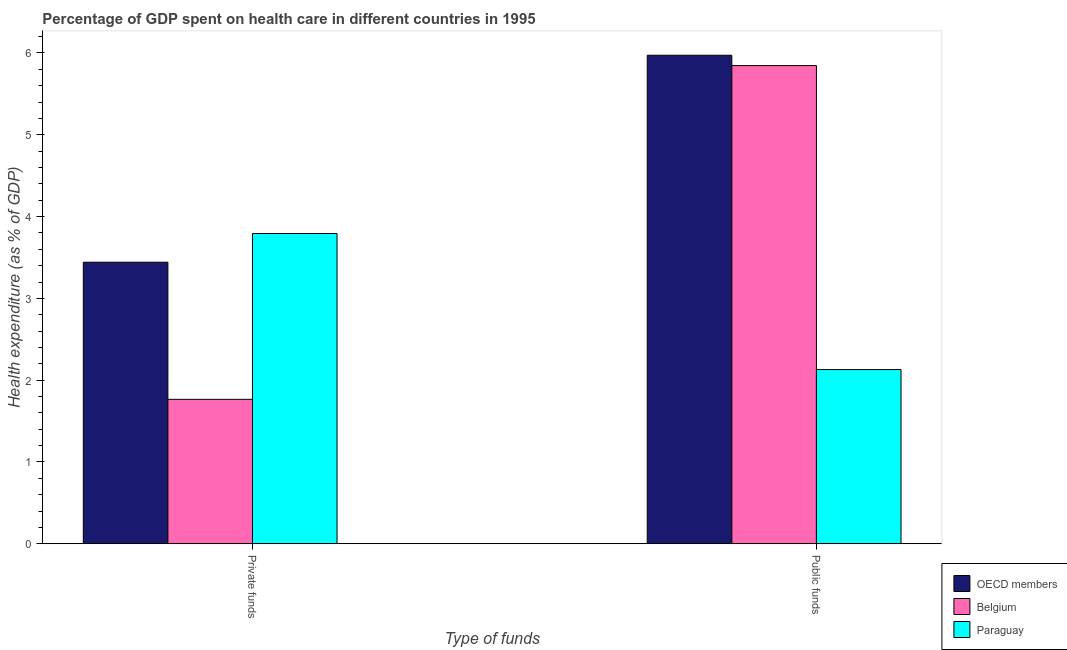How many different coloured bars are there?
Give a very brief answer. 3. Are the number of bars per tick equal to the number of legend labels?
Your answer should be very brief. Yes. How many bars are there on the 2nd tick from the left?
Make the answer very short. 3. What is the label of the 2nd group of bars from the left?
Provide a succinct answer. Public funds. What is the amount of public funds spent in healthcare in Belgium?
Keep it short and to the point. 5.85. Across all countries, what is the maximum amount of private funds spent in healthcare?
Offer a very short reply. 3.79. Across all countries, what is the minimum amount of private funds spent in healthcare?
Make the answer very short. 1.77. In which country was the amount of public funds spent in healthcare maximum?
Give a very brief answer. OECD members. In which country was the amount of private funds spent in healthcare minimum?
Your answer should be very brief. Belgium. What is the total amount of private funds spent in healthcare in the graph?
Make the answer very short. 9. What is the difference between the amount of public funds spent in healthcare in Paraguay and that in OECD members?
Offer a terse response. -3.84. What is the difference between the amount of public funds spent in healthcare in Paraguay and the amount of private funds spent in healthcare in Belgium?
Your answer should be compact. 0.36. What is the average amount of public funds spent in healthcare per country?
Your answer should be very brief. 4.65. What is the difference between the amount of private funds spent in healthcare and amount of public funds spent in healthcare in OECD members?
Offer a terse response. -2.53. What is the ratio of the amount of private funds spent in healthcare in Belgium to that in OECD members?
Provide a short and direct response. 0.51. What does the 1st bar from the right in Public funds represents?
Make the answer very short. Paraguay. What is the difference between two consecutive major ticks on the Y-axis?
Ensure brevity in your answer.  1. Are the values on the major ticks of Y-axis written in scientific E-notation?
Your answer should be compact. No. Does the graph contain any zero values?
Your answer should be very brief. No. Does the graph contain grids?
Make the answer very short. No. How many legend labels are there?
Your answer should be very brief. 3. How are the legend labels stacked?
Offer a terse response. Vertical. What is the title of the graph?
Keep it short and to the point. Percentage of GDP spent on health care in different countries in 1995. What is the label or title of the X-axis?
Offer a very short reply. Type of funds. What is the label or title of the Y-axis?
Keep it short and to the point. Health expenditure (as % of GDP). What is the Health expenditure (as % of GDP) of OECD members in Private funds?
Provide a short and direct response. 3.44. What is the Health expenditure (as % of GDP) in Belgium in Private funds?
Give a very brief answer. 1.77. What is the Health expenditure (as % of GDP) in Paraguay in Private funds?
Offer a terse response. 3.79. What is the Health expenditure (as % of GDP) of OECD members in Public funds?
Your response must be concise. 5.97. What is the Health expenditure (as % of GDP) in Belgium in Public funds?
Keep it short and to the point. 5.85. What is the Health expenditure (as % of GDP) of Paraguay in Public funds?
Provide a succinct answer. 2.13. Across all Type of funds, what is the maximum Health expenditure (as % of GDP) in OECD members?
Ensure brevity in your answer.  5.97. Across all Type of funds, what is the maximum Health expenditure (as % of GDP) of Belgium?
Make the answer very short. 5.85. Across all Type of funds, what is the maximum Health expenditure (as % of GDP) of Paraguay?
Offer a very short reply. 3.79. Across all Type of funds, what is the minimum Health expenditure (as % of GDP) in OECD members?
Offer a very short reply. 3.44. Across all Type of funds, what is the minimum Health expenditure (as % of GDP) of Belgium?
Provide a short and direct response. 1.77. Across all Type of funds, what is the minimum Health expenditure (as % of GDP) in Paraguay?
Offer a very short reply. 2.13. What is the total Health expenditure (as % of GDP) of OECD members in the graph?
Give a very brief answer. 9.41. What is the total Health expenditure (as % of GDP) of Belgium in the graph?
Your response must be concise. 7.61. What is the total Health expenditure (as % of GDP) of Paraguay in the graph?
Your response must be concise. 5.92. What is the difference between the Health expenditure (as % of GDP) in OECD members in Private funds and that in Public funds?
Keep it short and to the point. -2.53. What is the difference between the Health expenditure (as % of GDP) of Belgium in Private funds and that in Public funds?
Your answer should be very brief. -4.08. What is the difference between the Health expenditure (as % of GDP) in Paraguay in Private funds and that in Public funds?
Give a very brief answer. 1.66. What is the difference between the Health expenditure (as % of GDP) of OECD members in Private funds and the Health expenditure (as % of GDP) of Belgium in Public funds?
Ensure brevity in your answer.  -2.4. What is the difference between the Health expenditure (as % of GDP) of OECD members in Private funds and the Health expenditure (as % of GDP) of Paraguay in Public funds?
Make the answer very short. 1.31. What is the difference between the Health expenditure (as % of GDP) of Belgium in Private funds and the Health expenditure (as % of GDP) of Paraguay in Public funds?
Your response must be concise. -0.36. What is the average Health expenditure (as % of GDP) of OECD members per Type of funds?
Your response must be concise. 4.71. What is the average Health expenditure (as % of GDP) in Belgium per Type of funds?
Your answer should be compact. 3.81. What is the average Health expenditure (as % of GDP) in Paraguay per Type of funds?
Ensure brevity in your answer.  2.96. What is the difference between the Health expenditure (as % of GDP) of OECD members and Health expenditure (as % of GDP) of Belgium in Private funds?
Provide a succinct answer. 1.68. What is the difference between the Health expenditure (as % of GDP) in OECD members and Health expenditure (as % of GDP) in Paraguay in Private funds?
Ensure brevity in your answer.  -0.35. What is the difference between the Health expenditure (as % of GDP) of Belgium and Health expenditure (as % of GDP) of Paraguay in Private funds?
Ensure brevity in your answer.  -2.03. What is the difference between the Health expenditure (as % of GDP) of OECD members and Health expenditure (as % of GDP) of Belgium in Public funds?
Give a very brief answer. 0.13. What is the difference between the Health expenditure (as % of GDP) in OECD members and Health expenditure (as % of GDP) in Paraguay in Public funds?
Offer a terse response. 3.84. What is the difference between the Health expenditure (as % of GDP) of Belgium and Health expenditure (as % of GDP) of Paraguay in Public funds?
Your answer should be very brief. 3.72. What is the ratio of the Health expenditure (as % of GDP) of OECD members in Private funds to that in Public funds?
Your answer should be very brief. 0.58. What is the ratio of the Health expenditure (as % of GDP) in Belgium in Private funds to that in Public funds?
Your answer should be very brief. 0.3. What is the ratio of the Health expenditure (as % of GDP) in Paraguay in Private funds to that in Public funds?
Keep it short and to the point. 1.78. What is the difference between the highest and the second highest Health expenditure (as % of GDP) in OECD members?
Give a very brief answer. 2.53. What is the difference between the highest and the second highest Health expenditure (as % of GDP) in Belgium?
Ensure brevity in your answer.  4.08. What is the difference between the highest and the second highest Health expenditure (as % of GDP) of Paraguay?
Keep it short and to the point. 1.66. What is the difference between the highest and the lowest Health expenditure (as % of GDP) of OECD members?
Keep it short and to the point. 2.53. What is the difference between the highest and the lowest Health expenditure (as % of GDP) in Belgium?
Ensure brevity in your answer.  4.08. What is the difference between the highest and the lowest Health expenditure (as % of GDP) of Paraguay?
Your answer should be compact. 1.66. 